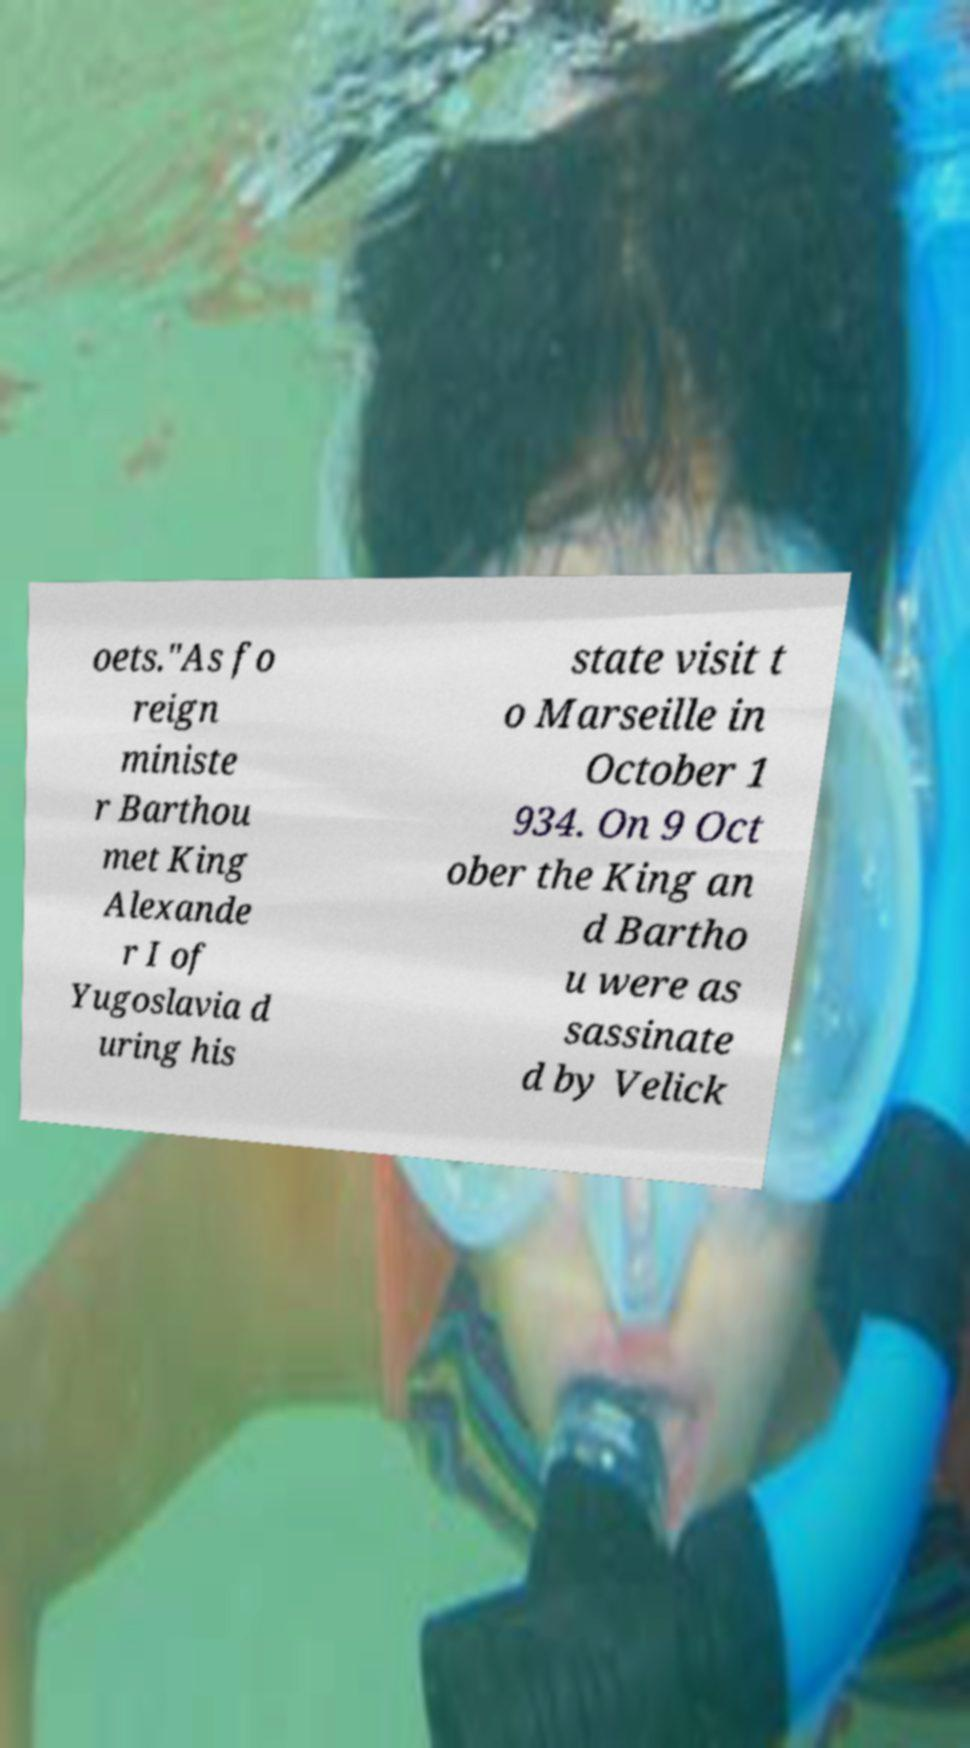For documentation purposes, I need the text within this image transcribed. Could you provide that? oets."As fo reign ministe r Barthou met King Alexande r I of Yugoslavia d uring his state visit t o Marseille in October 1 934. On 9 Oct ober the King an d Bartho u were as sassinate d by Velick 